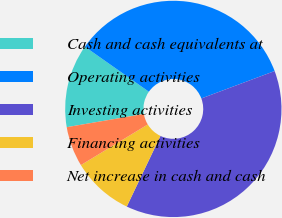<chart> <loc_0><loc_0><loc_500><loc_500><pie_chart><fcel>Cash and cash equivalents at<fcel>Operating activities<fcel>Investing activities<fcel>Financing activities<fcel>Net increase in cash and cash<nl><fcel>12.46%<fcel>34.55%<fcel>37.78%<fcel>9.23%<fcel>5.99%<nl></chart> 